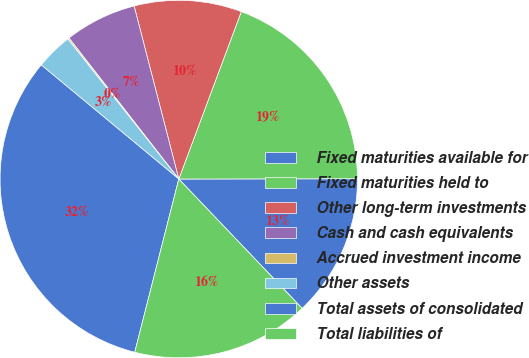Convert chart to OTSL. <chart><loc_0><loc_0><loc_500><loc_500><pie_chart><fcel>Fixed maturities available for<fcel>Fixed maturities held to<fcel>Other long-term investments<fcel>Cash and cash equivalents<fcel>Accrued investment income<fcel>Other assets<fcel>Total assets of consolidated<fcel>Total liabilities of<nl><fcel>12.9%<fcel>19.29%<fcel>9.71%<fcel>6.51%<fcel>0.13%<fcel>3.32%<fcel>32.06%<fcel>16.09%<nl></chart> 